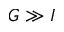Convert formula to latex. <formula><loc_0><loc_0><loc_500><loc_500>G \gg I</formula> 